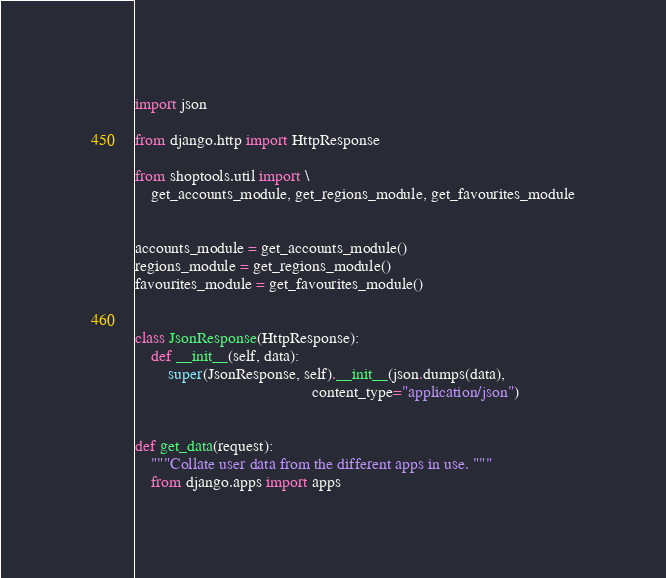Convert code to text. <code><loc_0><loc_0><loc_500><loc_500><_Python_>import json

from django.http import HttpResponse

from shoptools.util import \
    get_accounts_module, get_regions_module, get_favourites_module


accounts_module = get_accounts_module()
regions_module = get_regions_module()
favourites_module = get_favourites_module()


class JsonResponse(HttpResponse):
    def __init__(self, data):
        super(JsonResponse, self).__init__(json.dumps(data),
                                           content_type="application/json")


def get_data(request):
    """Collate user data from the different apps in use. """
    from django.apps import apps
</code> 